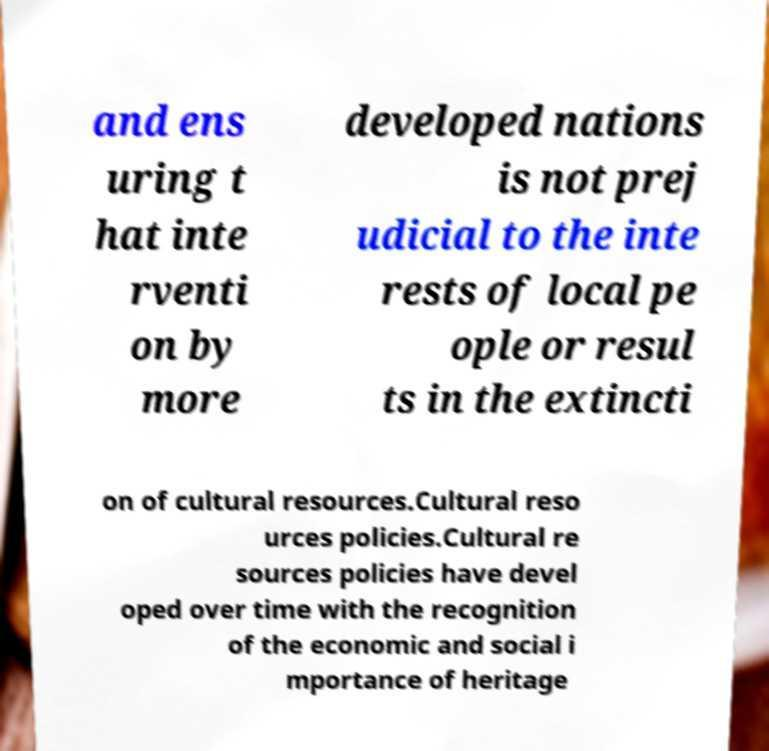For documentation purposes, I need the text within this image transcribed. Could you provide that? and ens uring t hat inte rventi on by more developed nations is not prej udicial to the inte rests of local pe ople or resul ts in the extincti on of cultural resources.Cultural reso urces policies.Cultural re sources policies have devel oped over time with the recognition of the economic and social i mportance of heritage 